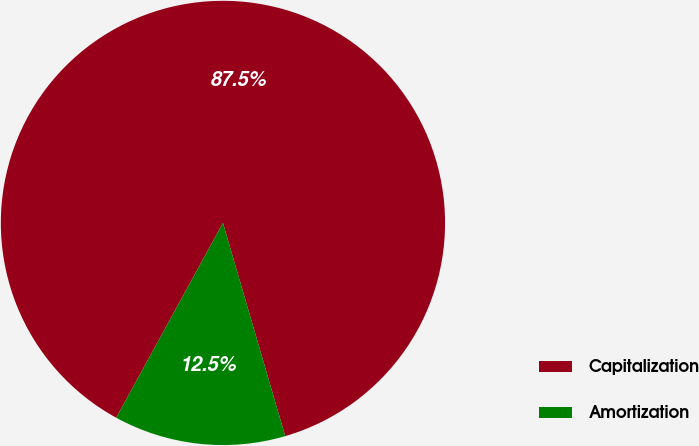<chart> <loc_0><loc_0><loc_500><loc_500><pie_chart><fcel>Capitalization<fcel>Amortization<nl><fcel>87.5%<fcel>12.5%<nl></chart> 